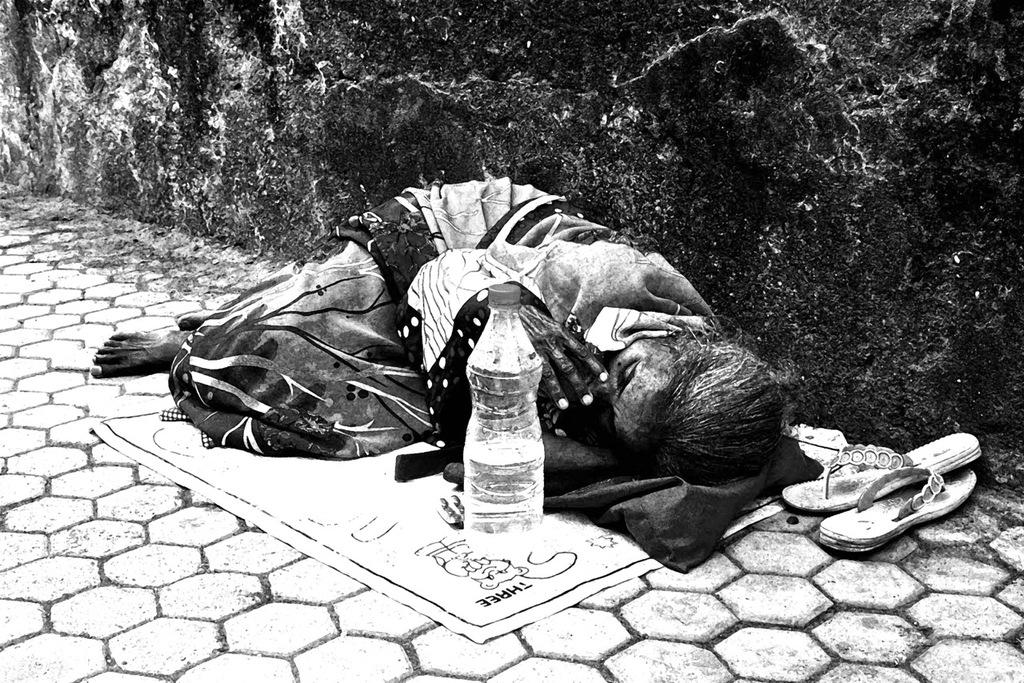What is the woman doing in the image? The woman is lying on the floor in the center of the image. What objects are in front of the woman? There is a water bottle and a paper in front of the woman. What can be seen on the right side of the image? There is a slipper on the right side of the image. What is visible in the background of the image? There is a wall in the background of the image. How many clouds can be seen in the image? There are no clouds visible in the image; it only shows a woman lying on the floor, objects in front of her, a slipper, and a wall in the background. 